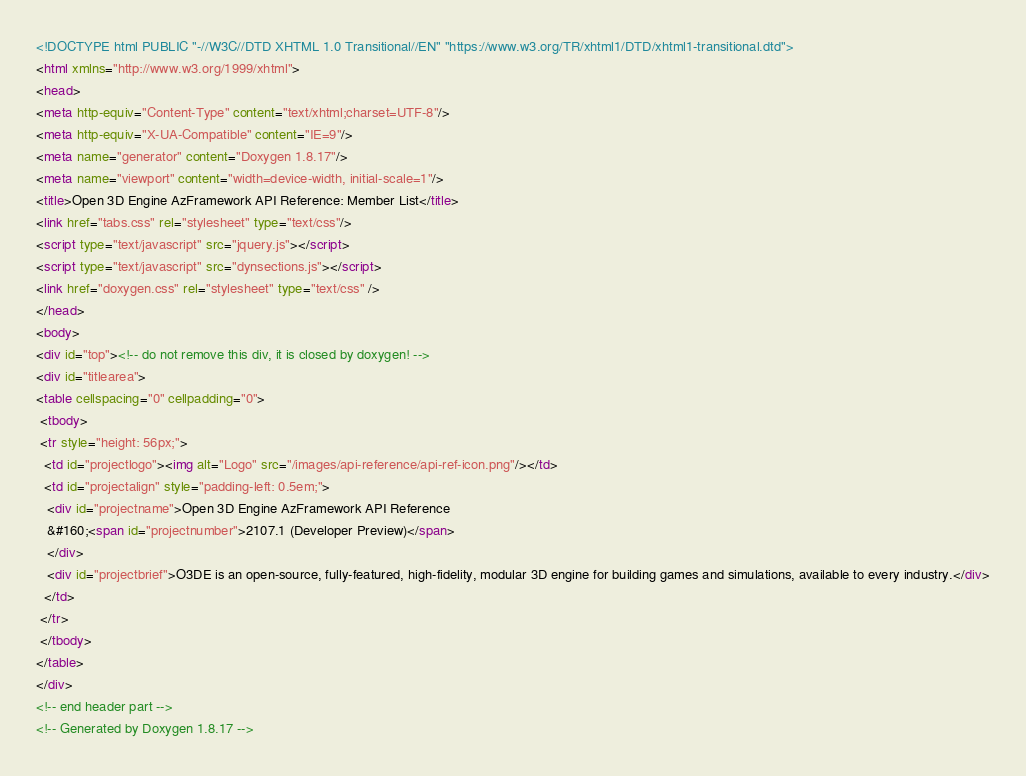<code> <loc_0><loc_0><loc_500><loc_500><_HTML_><!DOCTYPE html PUBLIC "-//W3C//DTD XHTML 1.0 Transitional//EN" "https://www.w3.org/TR/xhtml1/DTD/xhtml1-transitional.dtd">
<html xmlns="http://www.w3.org/1999/xhtml">
<head>
<meta http-equiv="Content-Type" content="text/xhtml;charset=UTF-8"/>
<meta http-equiv="X-UA-Compatible" content="IE=9"/>
<meta name="generator" content="Doxygen 1.8.17"/>
<meta name="viewport" content="width=device-width, initial-scale=1"/>
<title>Open 3D Engine AzFramework API Reference: Member List</title>
<link href="tabs.css" rel="stylesheet" type="text/css"/>
<script type="text/javascript" src="jquery.js"></script>
<script type="text/javascript" src="dynsections.js"></script>
<link href="doxygen.css" rel="stylesheet" type="text/css" />
</head>
<body>
<div id="top"><!-- do not remove this div, it is closed by doxygen! -->
<div id="titlearea">
<table cellspacing="0" cellpadding="0">
 <tbody>
 <tr style="height: 56px;">
  <td id="projectlogo"><img alt="Logo" src="/images/api-reference/api-ref-icon.png"/></td>
  <td id="projectalign" style="padding-left: 0.5em;">
   <div id="projectname">Open 3D Engine AzFramework API Reference
   &#160;<span id="projectnumber">2107.1 (Developer Preview)</span>
   </div>
   <div id="projectbrief">O3DE is an open-source, fully-featured, high-fidelity, modular 3D engine for building games and simulations, available to every industry.</div>
  </td>
 </tr>
 </tbody>
</table>
</div>
<!-- end header part -->
<!-- Generated by Doxygen 1.8.17 --></code> 